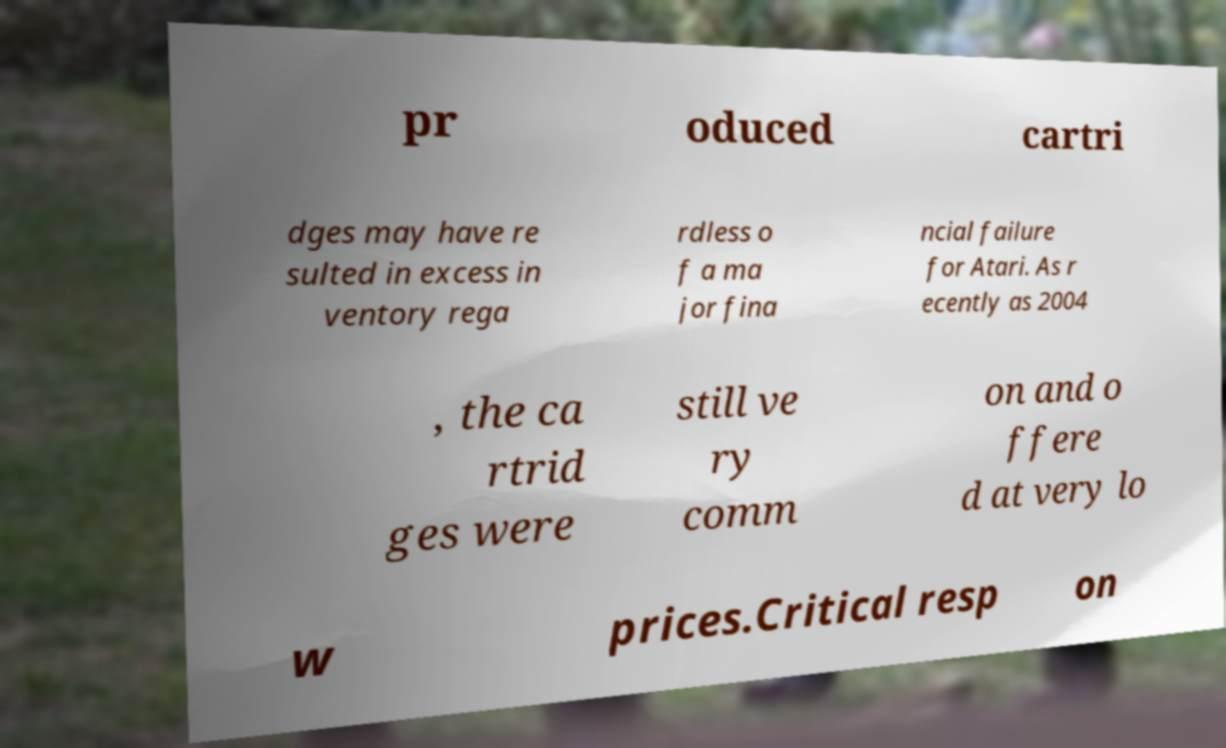Please identify and transcribe the text found in this image. pr oduced cartri dges may have re sulted in excess in ventory rega rdless o f a ma jor fina ncial failure for Atari. As r ecently as 2004 , the ca rtrid ges were still ve ry comm on and o ffere d at very lo w prices.Critical resp on 